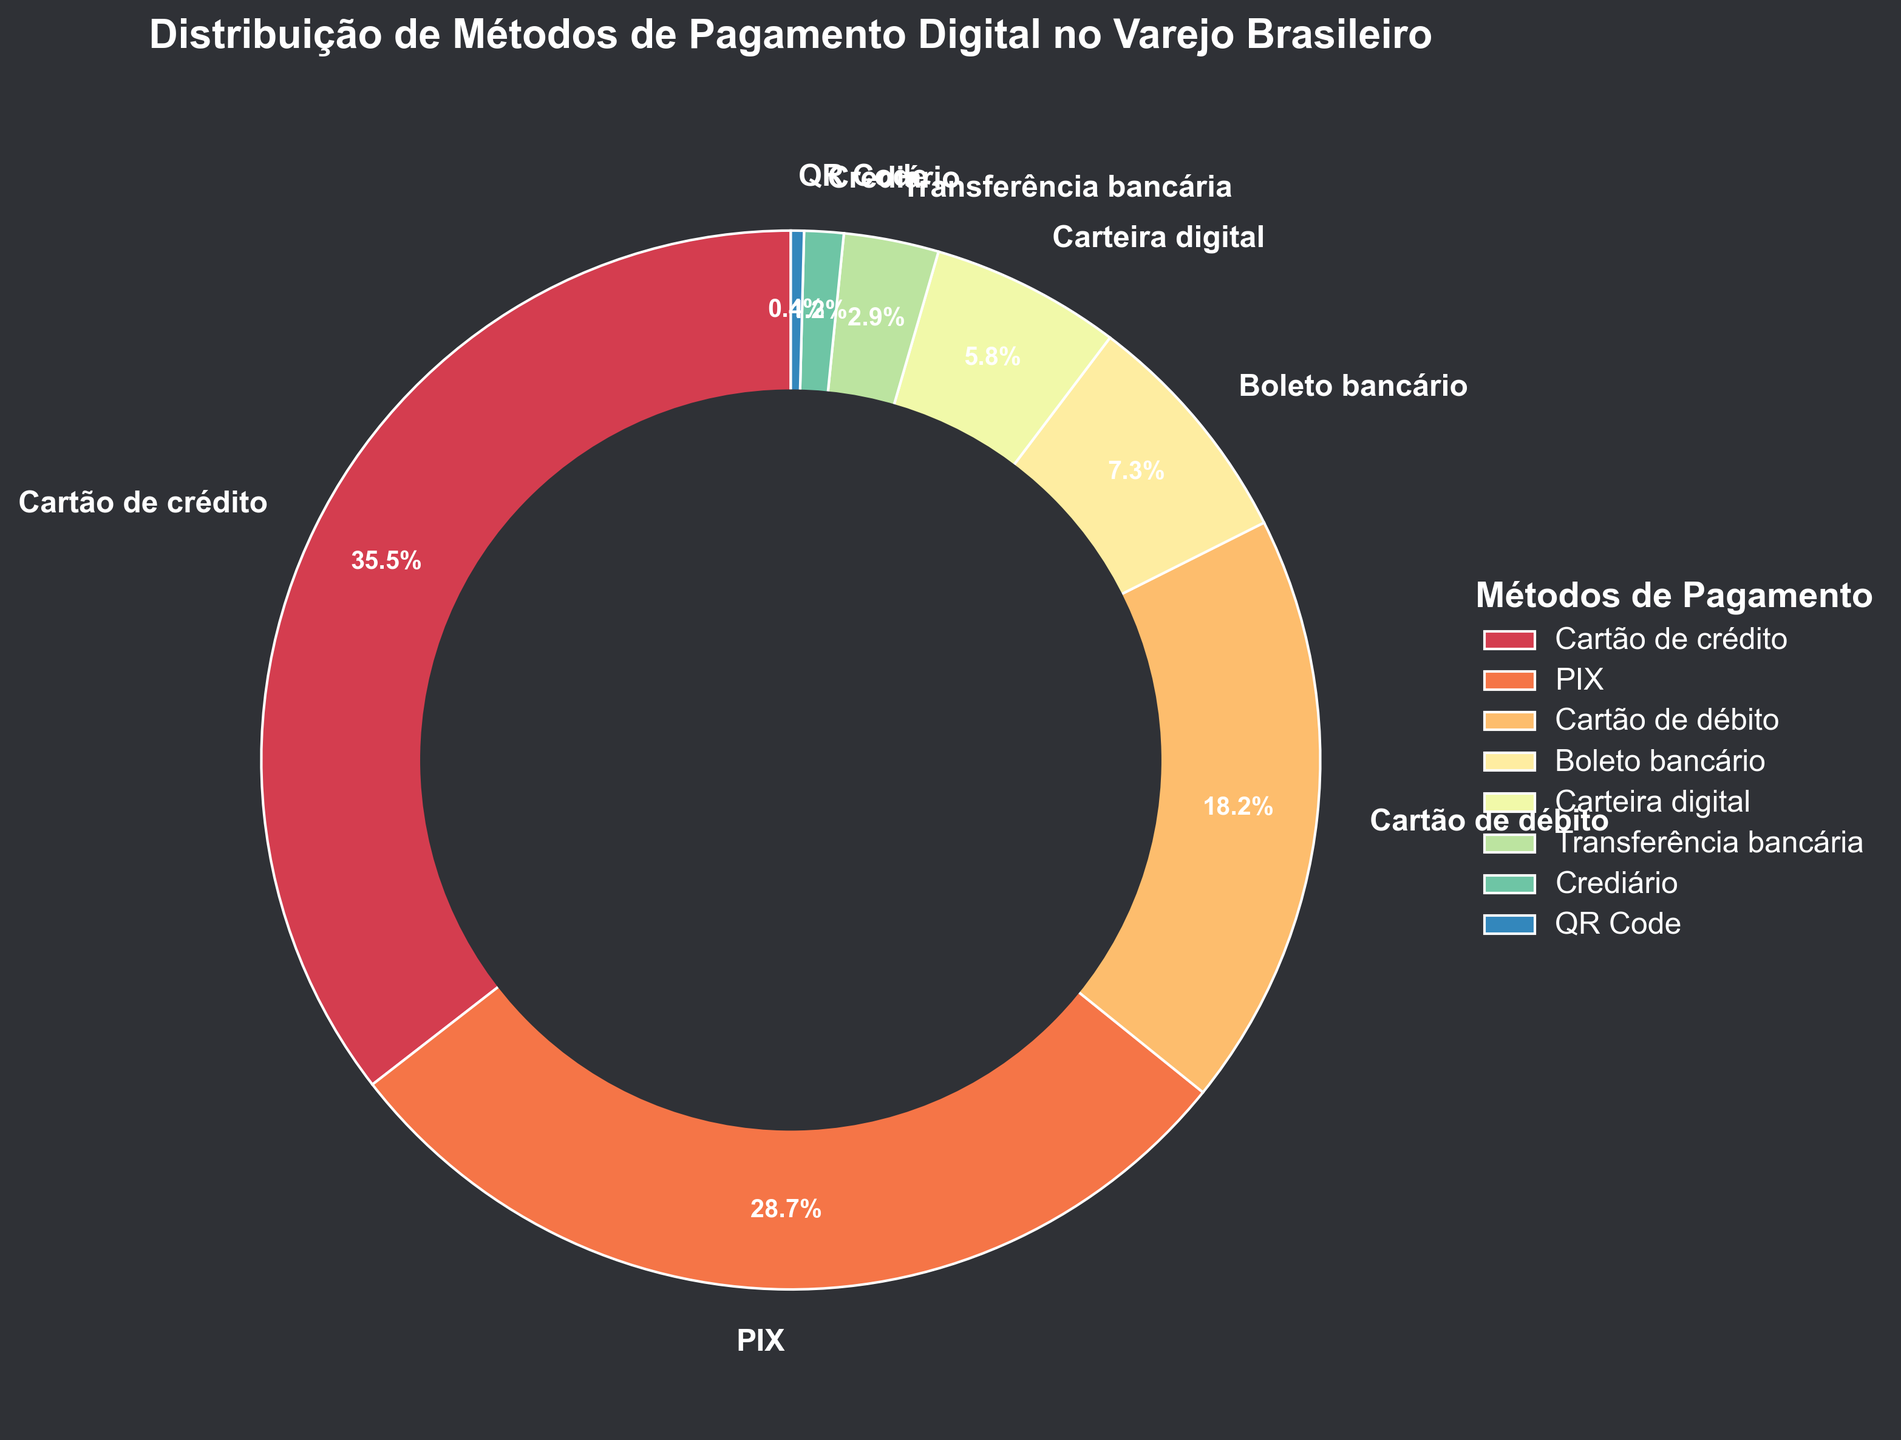What's the most popular digital payment method in Brazilian retail? The figure shows various digital payment methods with their respective percentages. To determine the most popular method, look for the one with the highest percentage.
Answer: Cartão de crédito Which two payment methods together make up more than 50% of the distribution? First, identify the two highest percentages from the figure, which are Cartão de crédito (35.5%) and PIX (28.7%). Adding these two percentages, we get 64.2%, which is more than 50%.
Answer: Cartão de crédito and PIX What's the combined percentage of Cartão de débito and Boleto bancário? From the figure, note the percentages of Cartão de débito (18.2%) and Boleto bancário (7.3%). Adding these together gives 25.5%.
Answer: 25.5% Is the percentage of Carteira digital greater than Transferência bancária? Look at the percentages for Carteira digital (5.8%) and Transferência bancária (2.9%). Compare these two values to see that Carteira digital's percentage is greater.
Answer: Yes What’s the total percentage of payment methods that individually make up less than 5% each? Identify the methods below 5%, which are Crediário (1.2%) and QR Code (0.4%). Sum these percentages to get 1.6%.
Answer: 1.6% How much lower is the percentage of Transferência bancária compared to PIX? From the figure, note the percentages for Transferência bancária (2.9%) and PIX (28.7%). Subtract the smaller percentage from the larger one: 28.7% - 2.9% = 25.8%.
Answer: 25.8% If you combine Cartão de crédito, Cartão de débito, and PIX, what percentage of the total distribution do they make up? Add the percentages of Cartão de crédito (35.5%), Cartão de débito (18.2%), and PIX (28.7%) to find their total: 35.5% + 18.2% + 28.7% = 82.4%.
Answer: 82.4% Is the percentage of Boleto bancário higher than the sum of Crediário and QR Code? Compare the percentage of Boleto bancário (7.3%) with the combined percentage of Crediário (1.2%) and QR Code (0.4%). The sum of these two is 1.6%, which is lower than 7.3%.
Answer: Yes What is the difference in percentage between Cartão de débito and Carteira digital? From the figure, note the percentages for Cartão de débito (18.2%) and Carteira digital (5.8%). Subtract the smaller percentage from the larger one: 18.2% - 5.8% = 12.4%.
Answer: 12.4% Which payment method has the smallest percentage, and what is it? Look for the payment method with the smallest slice in the pie chart. It is QR Code with 0.4%.
Answer: QR Code, 0.4% 